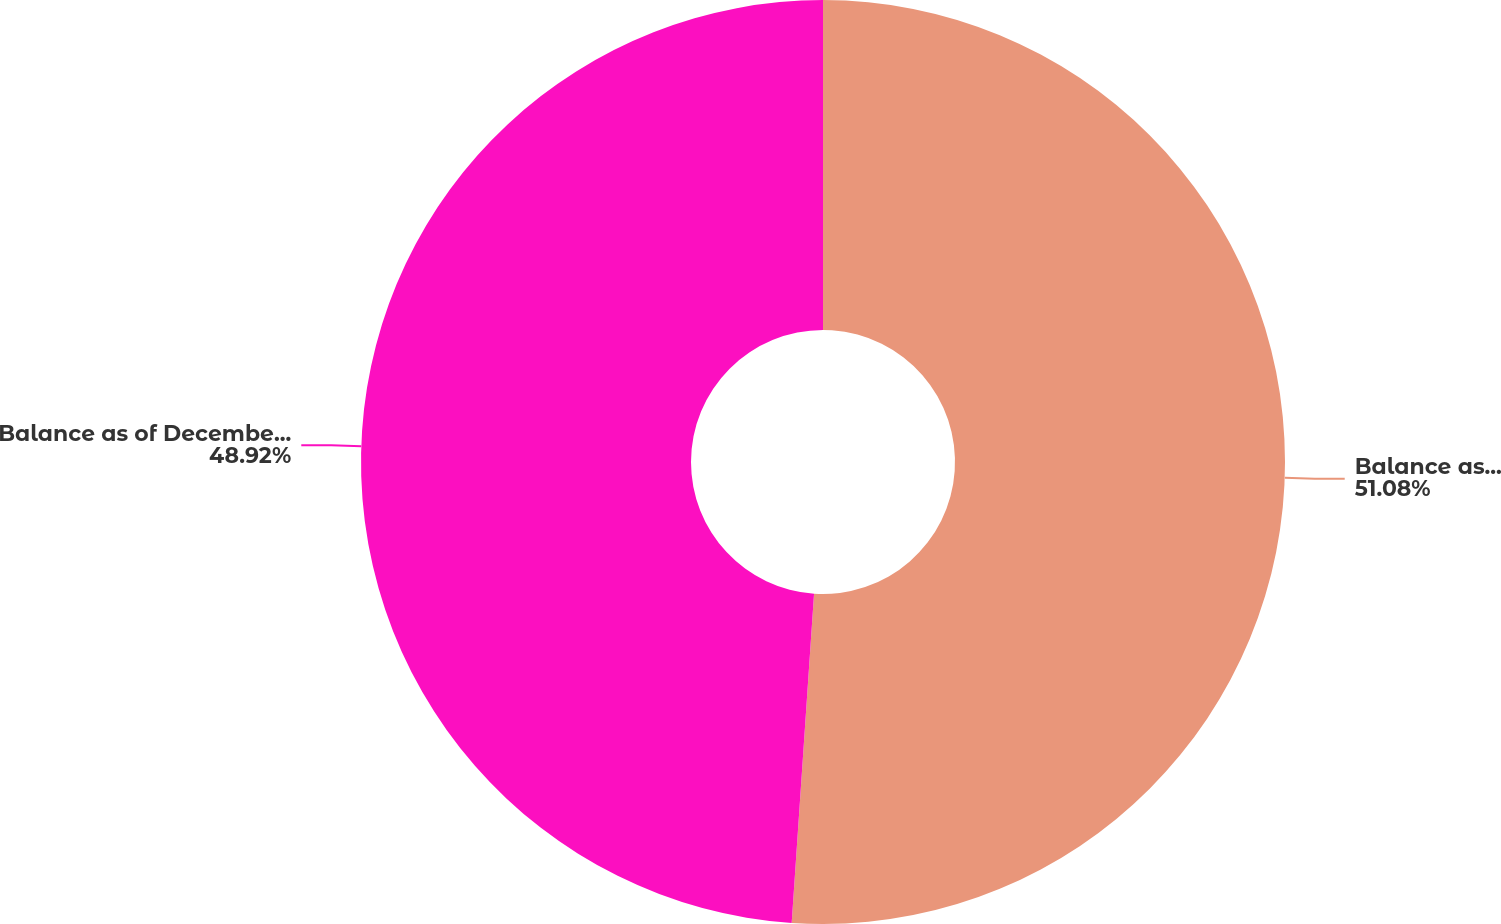Convert chart to OTSL. <chart><loc_0><loc_0><loc_500><loc_500><pie_chart><fcel>Balance as of December 31 2002<fcel>Balance as of December 31 2004<nl><fcel>51.08%<fcel>48.92%<nl></chart> 